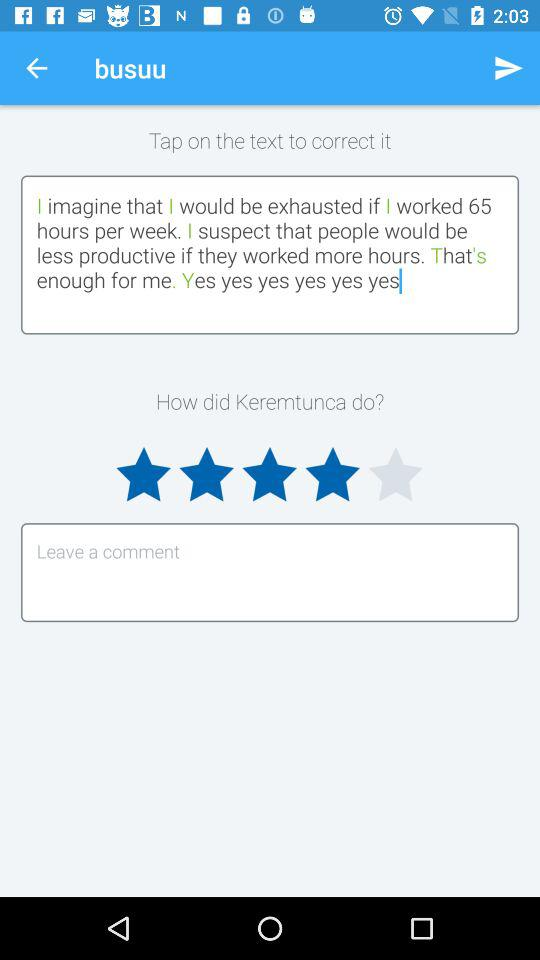What is the application Name?
When the provided information is insufficient, respond with <no answer>. <no answer> 